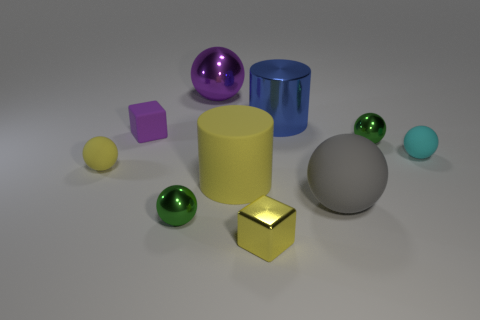There is a block that is behind the small yellow thing that is left of the large yellow matte thing; how big is it?
Your answer should be compact. Small. Is there anything else that has the same material as the yellow cube?
Offer a terse response. Yes. Is the number of small blocks greater than the number of big green matte cylinders?
Offer a very short reply. Yes. Does the large cylinder left of the blue cylinder have the same color as the ball behind the tiny purple thing?
Offer a very short reply. No. Is there a cyan rubber thing that is in front of the small rubber object in front of the small cyan matte object?
Your response must be concise. No. Are there fewer cyan objects that are behind the big blue metallic object than purple things that are on the right side of the gray rubber ball?
Your answer should be compact. No. Is the material of the small green thing that is to the left of the big yellow thing the same as the purple thing in front of the shiny cylinder?
Provide a succinct answer. No. How many big things are either rubber objects or shiny spheres?
Provide a succinct answer. 3. There is a tiny purple thing that is made of the same material as the large yellow cylinder; what is its shape?
Offer a terse response. Cube. Is the number of tiny rubber spheres that are on the left side of the cyan rubber ball less than the number of rubber spheres?
Make the answer very short. Yes. 